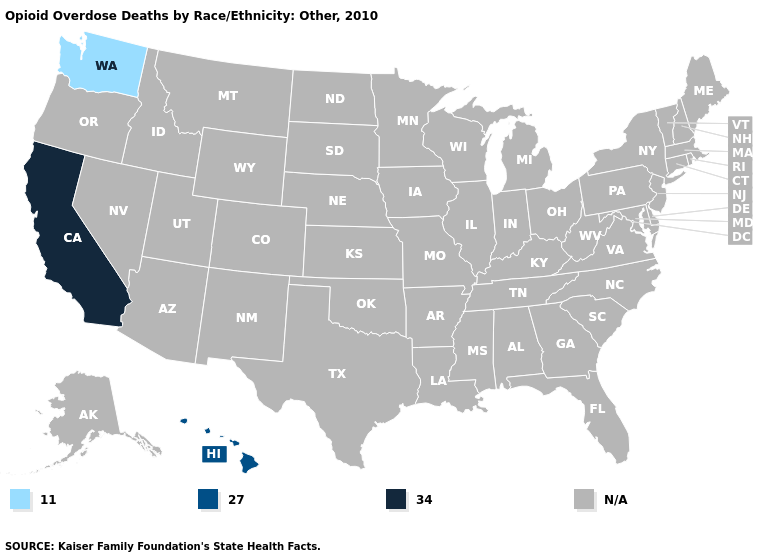What is the highest value in the West ?
Quick response, please. 34.0. Name the states that have a value in the range 11.0?
Write a very short answer. Washington. Name the states that have a value in the range 34.0?
Write a very short answer. California. Does Washington have the lowest value in the USA?
Write a very short answer. Yes. What is the value of Utah?
Short answer required. N/A. Name the states that have a value in the range 11.0?
Keep it brief. Washington. What is the lowest value in the USA?
Answer briefly. 11.0. Name the states that have a value in the range 34.0?
Give a very brief answer. California. Is the legend a continuous bar?
Quick response, please. No. Is the legend a continuous bar?
Be succinct. No. Which states have the highest value in the USA?
Keep it brief. California. Name the states that have a value in the range 11.0?
Quick response, please. Washington. Does the map have missing data?
Give a very brief answer. Yes. What is the value of Oregon?
Concise answer only. N/A. 